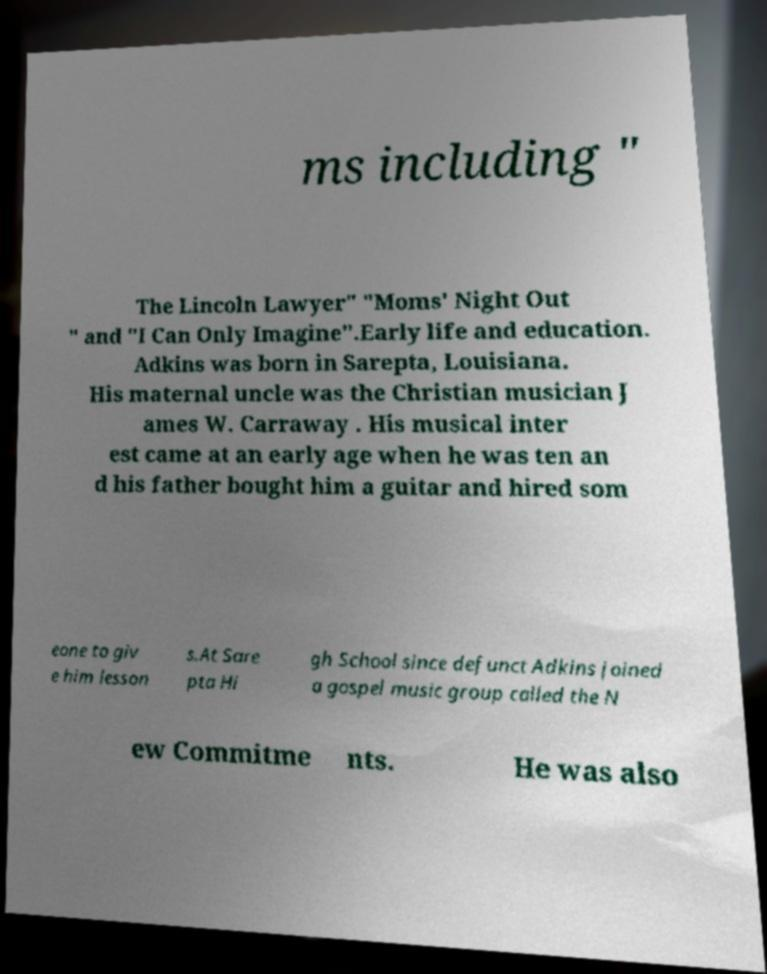Please read and relay the text visible in this image. What does it say? ms including " The Lincoln Lawyer" "Moms' Night Out " and "I Can Only Imagine".Early life and education. Adkins was born in Sarepta, Louisiana. His maternal uncle was the Christian musician J ames W. Carraway . His musical inter est came at an early age when he was ten an d his father bought him a guitar and hired som eone to giv e him lesson s.At Sare pta Hi gh School since defunct Adkins joined a gospel music group called the N ew Commitme nts. He was also 